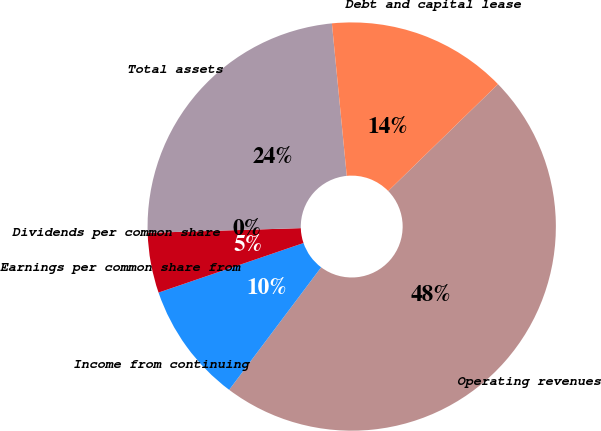Convert chart to OTSL. <chart><loc_0><loc_0><loc_500><loc_500><pie_chart><fcel>Operating revenues<fcel>Income from continuing<fcel>Earnings per common share from<fcel>Dividends per common share<fcel>Total assets<fcel>Debt and capital lease<nl><fcel>47.53%<fcel>9.51%<fcel>4.75%<fcel>0.0%<fcel>23.94%<fcel>14.26%<nl></chart> 